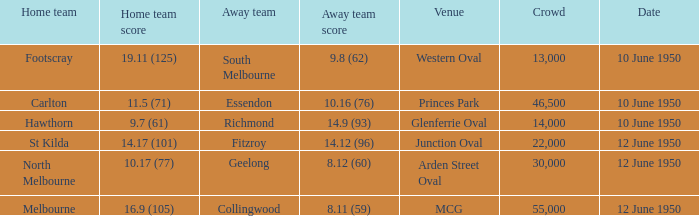What was the crowd when Melbourne was the home team? 55000.0. 